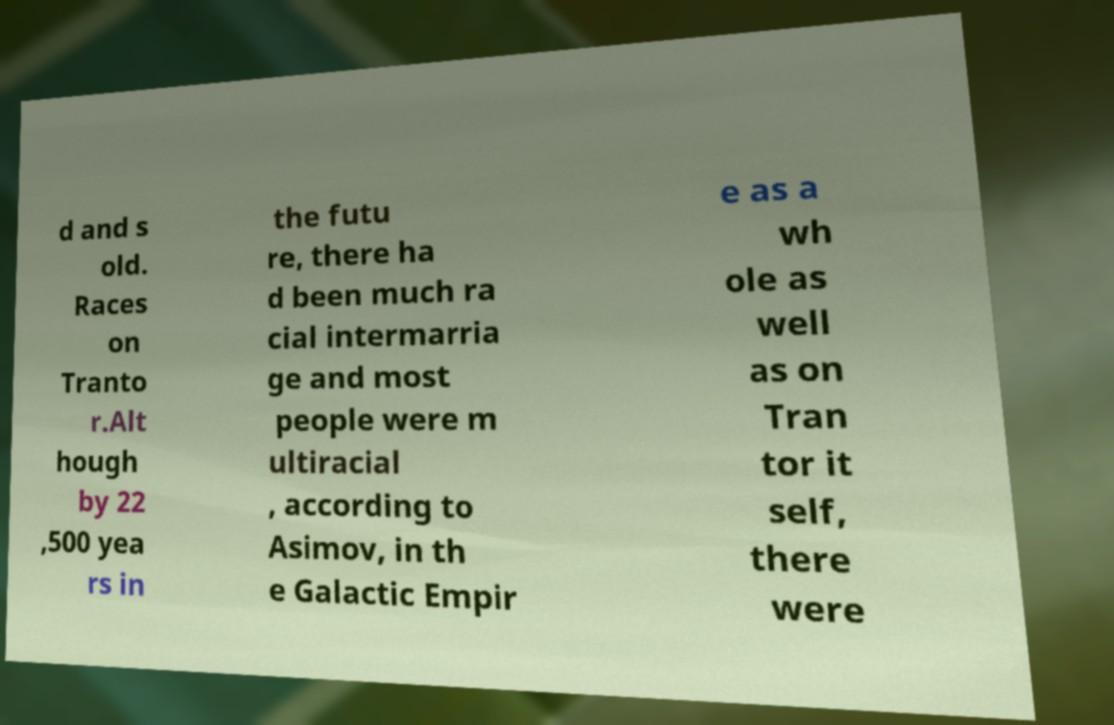There's text embedded in this image that I need extracted. Can you transcribe it verbatim? d and s old. Races on Tranto r.Alt hough by 22 ,500 yea rs in the futu re, there ha d been much ra cial intermarria ge and most people were m ultiracial , according to Asimov, in th e Galactic Empir e as a wh ole as well as on Tran tor it self, there were 